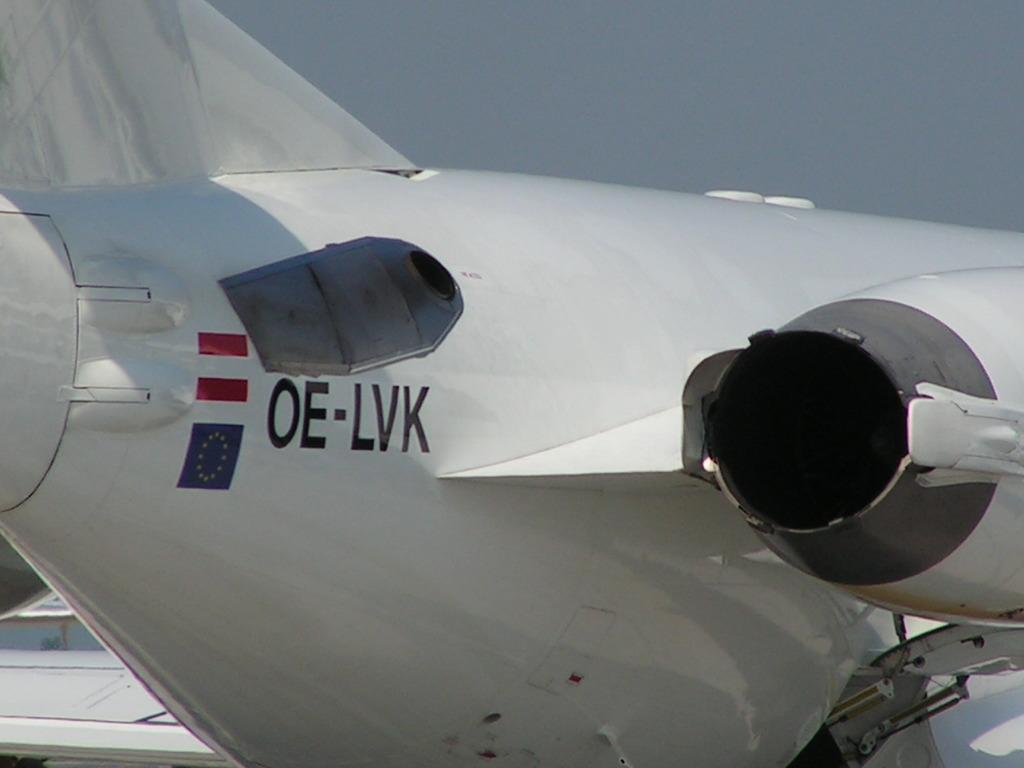<image>
Describe the image concisely. A white airplane with the letters OE-LVK and a flag 